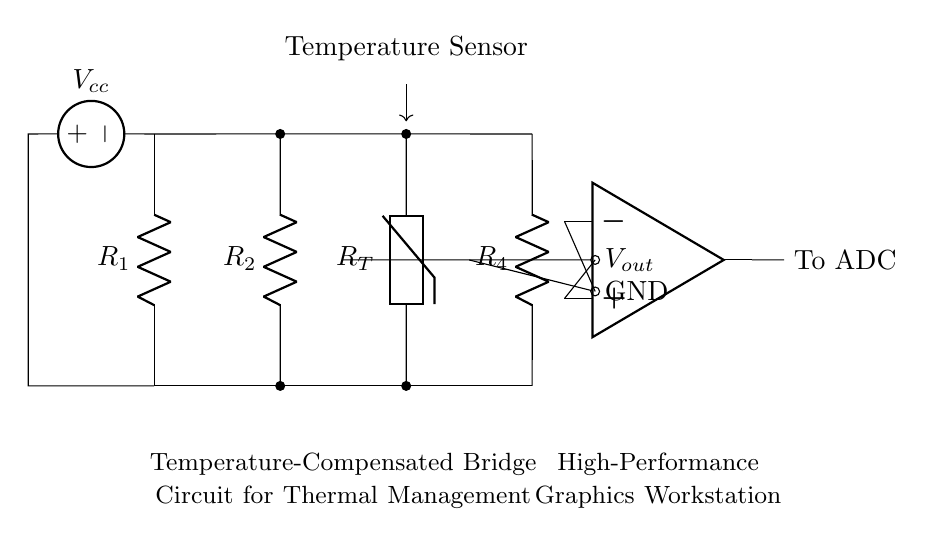What type of circuit is represented? The circuit diagram shows a bridge circuit, specifically a temperature-compensated bridge configuration. This is inferred from the arrangement of resistors and a thermistor in a specific layout characteristic of bridge circuits.
Answer: bridge circuit What component senses temperature? The temperature sensor is represented by the thermistor labeled as R_T in the circuit. Its placement in the bridge allows it to modify the resistance based on temperature changes, enabling temperature compensation.
Answer: thermistor How many resistors are in the circuit? There are four resistors in the circuit: R_1, R_2, R_4, and the thermistor labeled as R_T. Each of these components contributes to the balancing of the bridge.
Answer: four What is the function of the op-amp in the circuit? The operational amplifier (op-amp) is used to amplify the output voltage, V_out, from the bridge circuit for further processing or for input into an Analog-to-Digital Converter (ADC). This amplification is crucial in thermal management applications to ensure signal clarity.
Answer: amplify output What does V_out represent in the circuit? V_out represents the output voltage generated by the bridge circuit, which can be influenced by the voltage drop caused by the varying resistance of the thermistor with temperature changes. This voltage is essential for detection and control processes.
Answer: output voltage Why is temperature compensation necessary in this circuit? Temperature compensation is required to maintain the accuracy and reliability of voltage output V_out despite changes in temperature, which can affect resistor values and lead to incorrect readings. This ensures consistent performance in high-performance graphics workstations.
Answer: maintain accuracy 